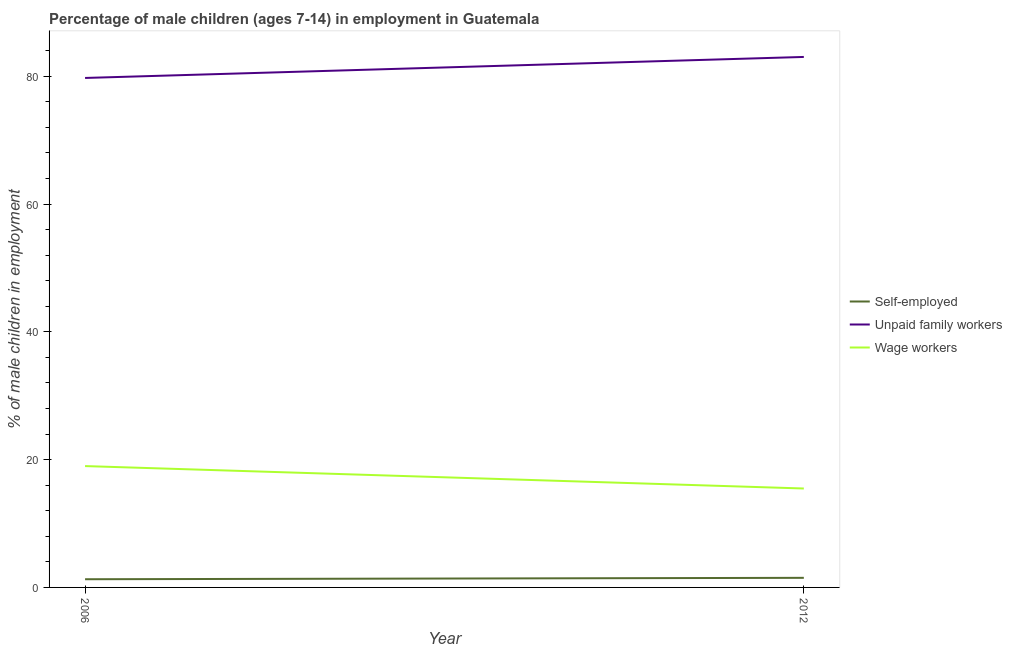Does the line corresponding to percentage of children employed as wage workers intersect with the line corresponding to percentage of children employed as unpaid family workers?
Your answer should be compact. No. Is the number of lines equal to the number of legend labels?
Make the answer very short. Yes. What is the percentage of children employed as wage workers in 2006?
Make the answer very short. 18.99. Across all years, what is the maximum percentage of children employed as unpaid family workers?
Ensure brevity in your answer.  83.02. Across all years, what is the minimum percentage of self employed children?
Give a very brief answer. 1.28. In which year was the percentage of children employed as wage workers maximum?
Offer a very short reply. 2006. In which year was the percentage of self employed children minimum?
Offer a terse response. 2006. What is the total percentage of children employed as wage workers in the graph?
Provide a short and direct response. 34.47. What is the difference between the percentage of children employed as wage workers in 2006 and that in 2012?
Your answer should be compact. 3.51. What is the difference between the percentage of children employed as wage workers in 2012 and the percentage of self employed children in 2006?
Ensure brevity in your answer.  14.2. What is the average percentage of children employed as unpaid family workers per year?
Offer a terse response. 81.38. In the year 2006, what is the difference between the percentage of children employed as unpaid family workers and percentage of self employed children?
Ensure brevity in your answer.  78.45. In how many years, is the percentage of children employed as wage workers greater than 24 %?
Make the answer very short. 0. What is the ratio of the percentage of children employed as wage workers in 2006 to that in 2012?
Your answer should be very brief. 1.23. In how many years, is the percentage of children employed as unpaid family workers greater than the average percentage of children employed as unpaid family workers taken over all years?
Ensure brevity in your answer.  1. Does the percentage of children employed as unpaid family workers monotonically increase over the years?
Offer a terse response. Yes. Is the percentage of children employed as wage workers strictly less than the percentage of self employed children over the years?
Give a very brief answer. No. How many years are there in the graph?
Offer a very short reply. 2. What is the difference between two consecutive major ticks on the Y-axis?
Ensure brevity in your answer.  20. Are the values on the major ticks of Y-axis written in scientific E-notation?
Give a very brief answer. No. Does the graph contain any zero values?
Keep it short and to the point. No. Where does the legend appear in the graph?
Ensure brevity in your answer.  Center right. What is the title of the graph?
Give a very brief answer. Percentage of male children (ages 7-14) in employment in Guatemala. Does "Taxes on international trade" appear as one of the legend labels in the graph?
Keep it short and to the point. No. What is the label or title of the Y-axis?
Make the answer very short. % of male children in employment. What is the % of male children in employment of Self-employed in 2006?
Ensure brevity in your answer.  1.28. What is the % of male children in employment in Unpaid family workers in 2006?
Offer a very short reply. 79.73. What is the % of male children in employment in Wage workers in 2006?
Provide a short and direct response. 18.99. What is the % of male children in employment of Unpaid family workers in 2012?
Give a very brief answer. 83.02. What is the % of male children in employment of Wage workers in 2012?
Offer a terse response. 15.48. Across all years, what is the maximum % of male children in employment of Self-employed?
Offer a terse response. 1.5. Across all years, what is the maximum % of male children in employment of Unpaid family workers?
Make the answer very short. 83.02. Across all years, what is the maximum % of male children in employment in Wage workers?
Provide a short and direct response. 18.99. Across all years, what is the minimum % of male children in employment in Self-employed?
Provide a succinct answer. 1.28. Across all years, what is the minimum % of male children in employment of Unpaid family workers?
Offer a terse response. 79.73. Across all years, what is the minimum % of male children in employment in Wage workers?
Keep it short and to the point. 15.48. What is the total % of male children in employment in Self-employed in the graph?
Provide a short and direct response. 2.78. What is the total % of male children in employment in Unpaid family workers in the graph?
Give a very brief answer. 162.75. What is the total % of male children in employment of Wage workers in the graph?
Your answer should be compact. 34.47. What is the difference between the % of male children in employment in Self-employed in 2006 and that in 2012?
Your answer should be compact. -0.22. What is the difference between the % of male children in employment of Unpaid family workers in 2006 and that in 2012?
Offer a terse response. -3.29. What is the difference between the % of male children in employment in Wage workers in 2006 and that in 2012?
Ensure brevity in your answer.  3.51. What is the difference between the % of male children in employment of Self-employed in 2006 and the % of male children in employment of Unpaid family workers in 2012?
Offer a very short reply. -81.74. What is the difference between the % of male children in employment in Unpaid family workers in 2006 and the % of male children in employment in Wage workers in 2012?
Ensure brevity in your answer.  64.25. What is the average % of male children in employment in Self-employed per year?
Your response must be concise. 1.39. What is the average % of male children in employment in Unpaid family workers per year?
Keep it short and to the point. 81.38. What is the average % of male children in employment in Wage workers per year?
Your answer should be very brief. 17.23. In the year 2006, what is the difference between the % of male children in employment of Self-employed and % of male children in employment of Unpaid family workers?
Make the answer very short. -78.45. In the year 2006, what is the difference between the % of male children in employment of Self-employed and % of male children in employment of Wage workers?
Give a very brief answer. -17.71. In the year 2006, what is the difference between the % of male children in employment in Unpaid family workers and % of male children in employment in Wage workers?
Keep it short and to the point. 60.74. In the year 2012, what is the difference between the % of male children in employment of Self-employed and % of male children in employment of Unpaid family workers?
Provide a succinct answer. -81.52. In the year 2012, what is the difference between the % of male children in employment in Self-employed and % of male children in employment in Wage workers?
Keep it short and to the point. -13.98. In the year 2012, what is the difference between the % of male children in employment of Unpaid family workers and % of male children in employment of Wage workers?
Offer a very short reply. 67.54. What is the ratio of the % of male children in employment in Self-employed in 2006 to that in 2012?
Offer a very short reply. 0.85. What is the ratio of the % of male children in employment in Unpaid family workers in 2006 to that in 2012?
Provide a short and direct response. 0.96. What is the ratio of the % of male children in employment of Wage workers in 2006 to that in 2012?
Provide a succinct answer. 1.23. What is the difference between the highest and the second highest % of male children in employment of Self-employed?
Your answer should be compact. 0.22. What is the difference between the highest and the second highest % of male children in employment of Unpaid family workers?
Offer a very short reply. 3.29. What is the difference between the highest and the second highest % of male children in employment in Wage workers?
Your answer should be compact. 3.51. What is the difference between the highest and the lowest % of male children in employment of Self-employed?
Give a very brief answer. 0.22. What is the difference between the highest and the lowest % of male children in employment of Unpaid family workers?
Provide a succinct answer. 3.29. What is the difference between the highest and the lowest % of male children in employment of Wage workers?
Your answer should be very brief. 3.51. 